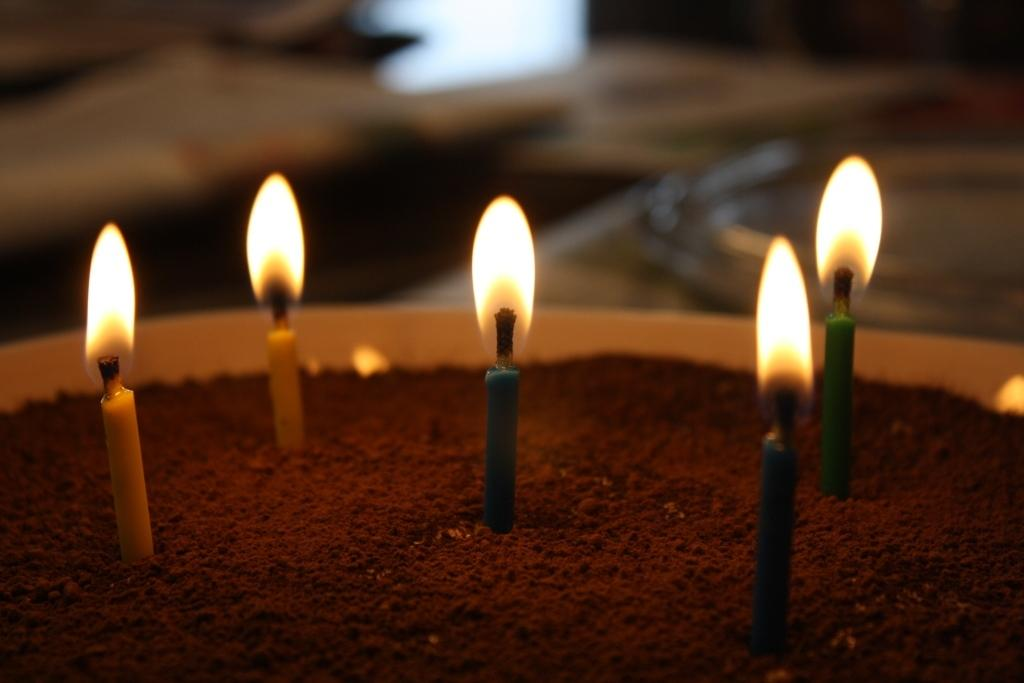What objects can be seen in the image? There are candles in the image. What is the state of the candles? The candles are lightened up. Where are the candles located? The candles are present over a place. What type of thing is playing the fifth instrument in the band in the image? There is no band or instruments present in the image; it only features candles. 